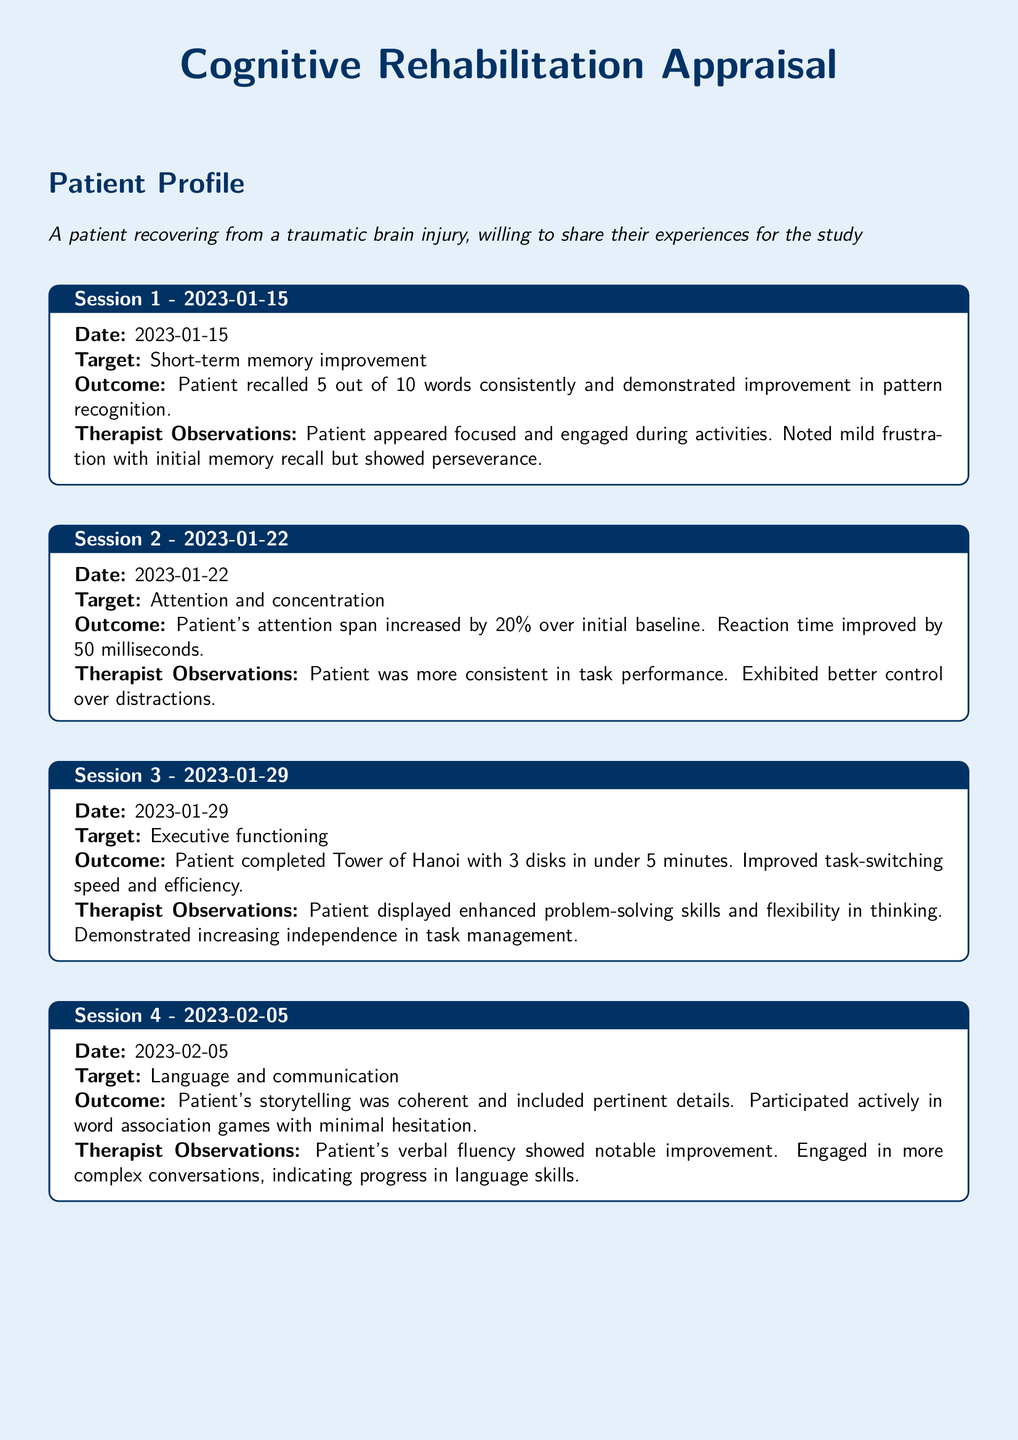What is the date of the first session? The date of the first session is clearly stated in the document as 2023-01-15.
Answer: 2023-01-15 What was the target for the second session? The target for the second session is mentioned as attention and concentration in the document.
Answer: Attention and concentration What percentage improvement was noted in the patient's attention span? The document specifies that the attention span increased by 20% over the initial baseline during the second session.
Answer: 20% What task did the patient complete in the third session? The specific task mentioned is the Tower of Hanoi with 3 disks, completed in under 5 minutes.
Answer: Tower of Hanoi Which skill improved during session four? The document indicates that the patient's verbal fluency showed notable improvement during this session.
Answer: Verbal fluency How many emotions did the patient identify correctly in session five? The document states that the patient accurately identified emotions in 80% of the scenarios during the fifth session.
Answer: 80% What observation was noted about the patient’s social interactions in session five? The therapist observed that the patient showed more confidence in social interactions during the fifth session.
Answer: More confident Which session involved improvement in problem-solving skills? The session that involved improvement in problem-solving skills is the third session, as mentioned in the document.
Answer: Session 3 What was a significant outcome observed during session one? A significant outcome noted was that the patient recalled 5 out of 10 words consistently during the first session.
Answer: Recalled 5 out of 10 words 